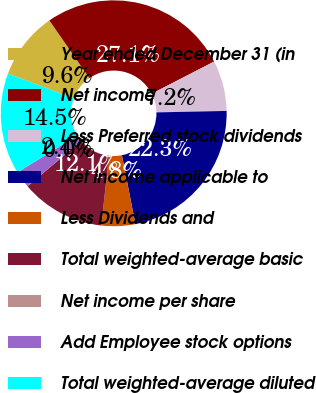Convert chart. <chart><loc_0><loc_0><loc_500><loc_500><pie_chart><fcel>Year ended December 31 (in<fcel>Net income<fcel>Less Preferred stock dividends<fcel>Net income applicable to<fcel>Less Dividends and<fcel>Total weighted-average basic<fcel>Net income per share<fcel>Add Employee stock options<fcel>Total weighted-average diluted<nl><fcel>9.65%<fcel>27.08%<fcel>7.24%<fcel>22.26%<fcel>4.83%<fcel>12.06%<fcel>0.01%<fcel>2.42%<fcel>14.47%<nl></chart> 